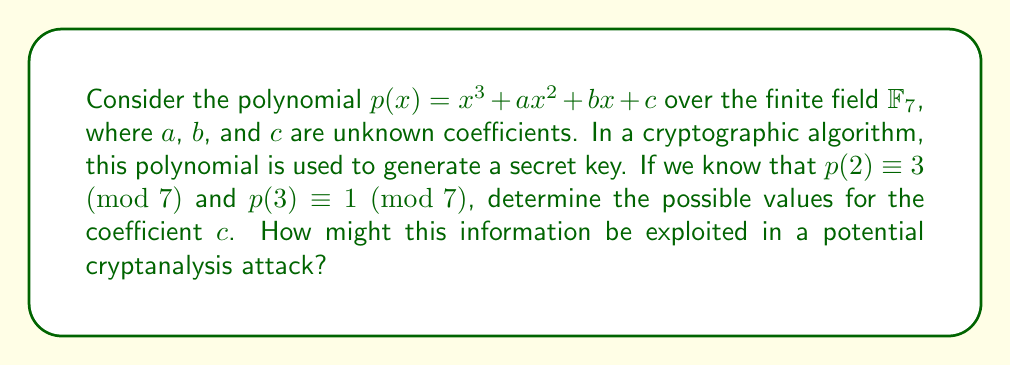Could you help me with this problem? To solve this problem, we need to use polynomial arithmetic in the finite field $\mathbb{F}_7$. Let's approach this step-by-step:

1) First, let's evaluate $p(2) \equiv 3 \pmod{7}$:
   $$2^3 + a2^2 + b2 + c \equiv 3 \pmod{7}$$
   $$8 + 4a + 2b + c \equiv 3 \pmod{7}$$
   $$1 + 4a + 2b + c \equiv 3 \pmod{7}$$ (since $8 \equiv 1 \pmod{7}$)

2) Now, let's evaluate $p(3) \equiv 1 \pmod{7}$:
   $$3^3 + a3^2 + b3 + c \equiv 1 \pmod{7}$$
   $$27 + 9a + 3b + c \equiv 1 \pmod{7}$$
   $$6 + 2a + 3b + c \equiv 1 \pmod{7}$$ (since $27 \equiv 6 \pmod{7}$ and $9 \equiv 2 \pmod{7}$)

3) We now have a system of two congruences:
   $$4a + 2b + c \equiv 2 \pmod{7}$$ (subtracting 1 from both sides in equation 1)
   $$2a + 3b + c \equiv 2 \pmod{7}$$ (subtracting 6 from both sides in equation 2)

4) Subtracting the second equation from the first:
   $$2a - b \equiv 0 \pmod{7}$$
   $$b \equiv 2a \pmod{7}$$

5) Substituting this back into the first equation:
   $$4a + 2(2a) + c \equiv 2 \pmod{7}$$
   $$4a + 4a + c \equiv 2 \pmod{7}$$
   $$a + c \equiv 2 \pmod{7}$$

6) This means that $c$ can take any value in $\mathbb{F}_7$, and $a$ will adjust accordingly to satisfy the congruence.

In terms of cryptanalysis, this result shows that knowing two evaluations of the polynomial is not sufficient to uniquely determine the coefficients. This ambiguity could potentially be exploited in a cryptanalytic attack by reducing the search space for the secret key. However, it also demonstrates a level of security, as multiple valid solutions exist, making it harder for an attacker to pinpoint the exact key.
Answer: The coefficient $c$ can take any value in $\mathbb{F}_7 = \{0, 1, 2, 3, 4, 5, 6\}$. This ambiguity in determining $c$ provides some security against simple interpolation attacks, but also potentially reduces the key space, which could be exploited in more sophisticated cryptanalytic approaches. 